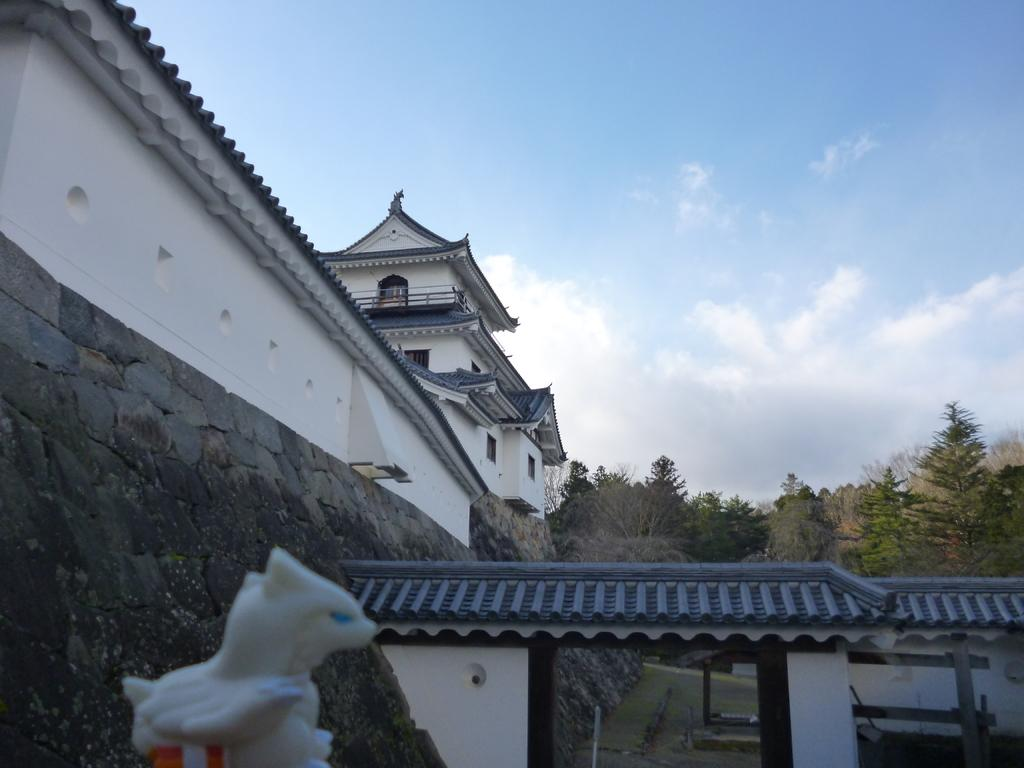What is the main structure visible in the image? There is a building in the image. Are there any other objects or features near the building? Yes, there are trees beside the building in the image. What type of ear is visible on the building in the image? There is no ear visible on the building in the image. What attraction is located near the building in the image? The provided facts do not mention any attractions near the building, so we cannot answer this question. 